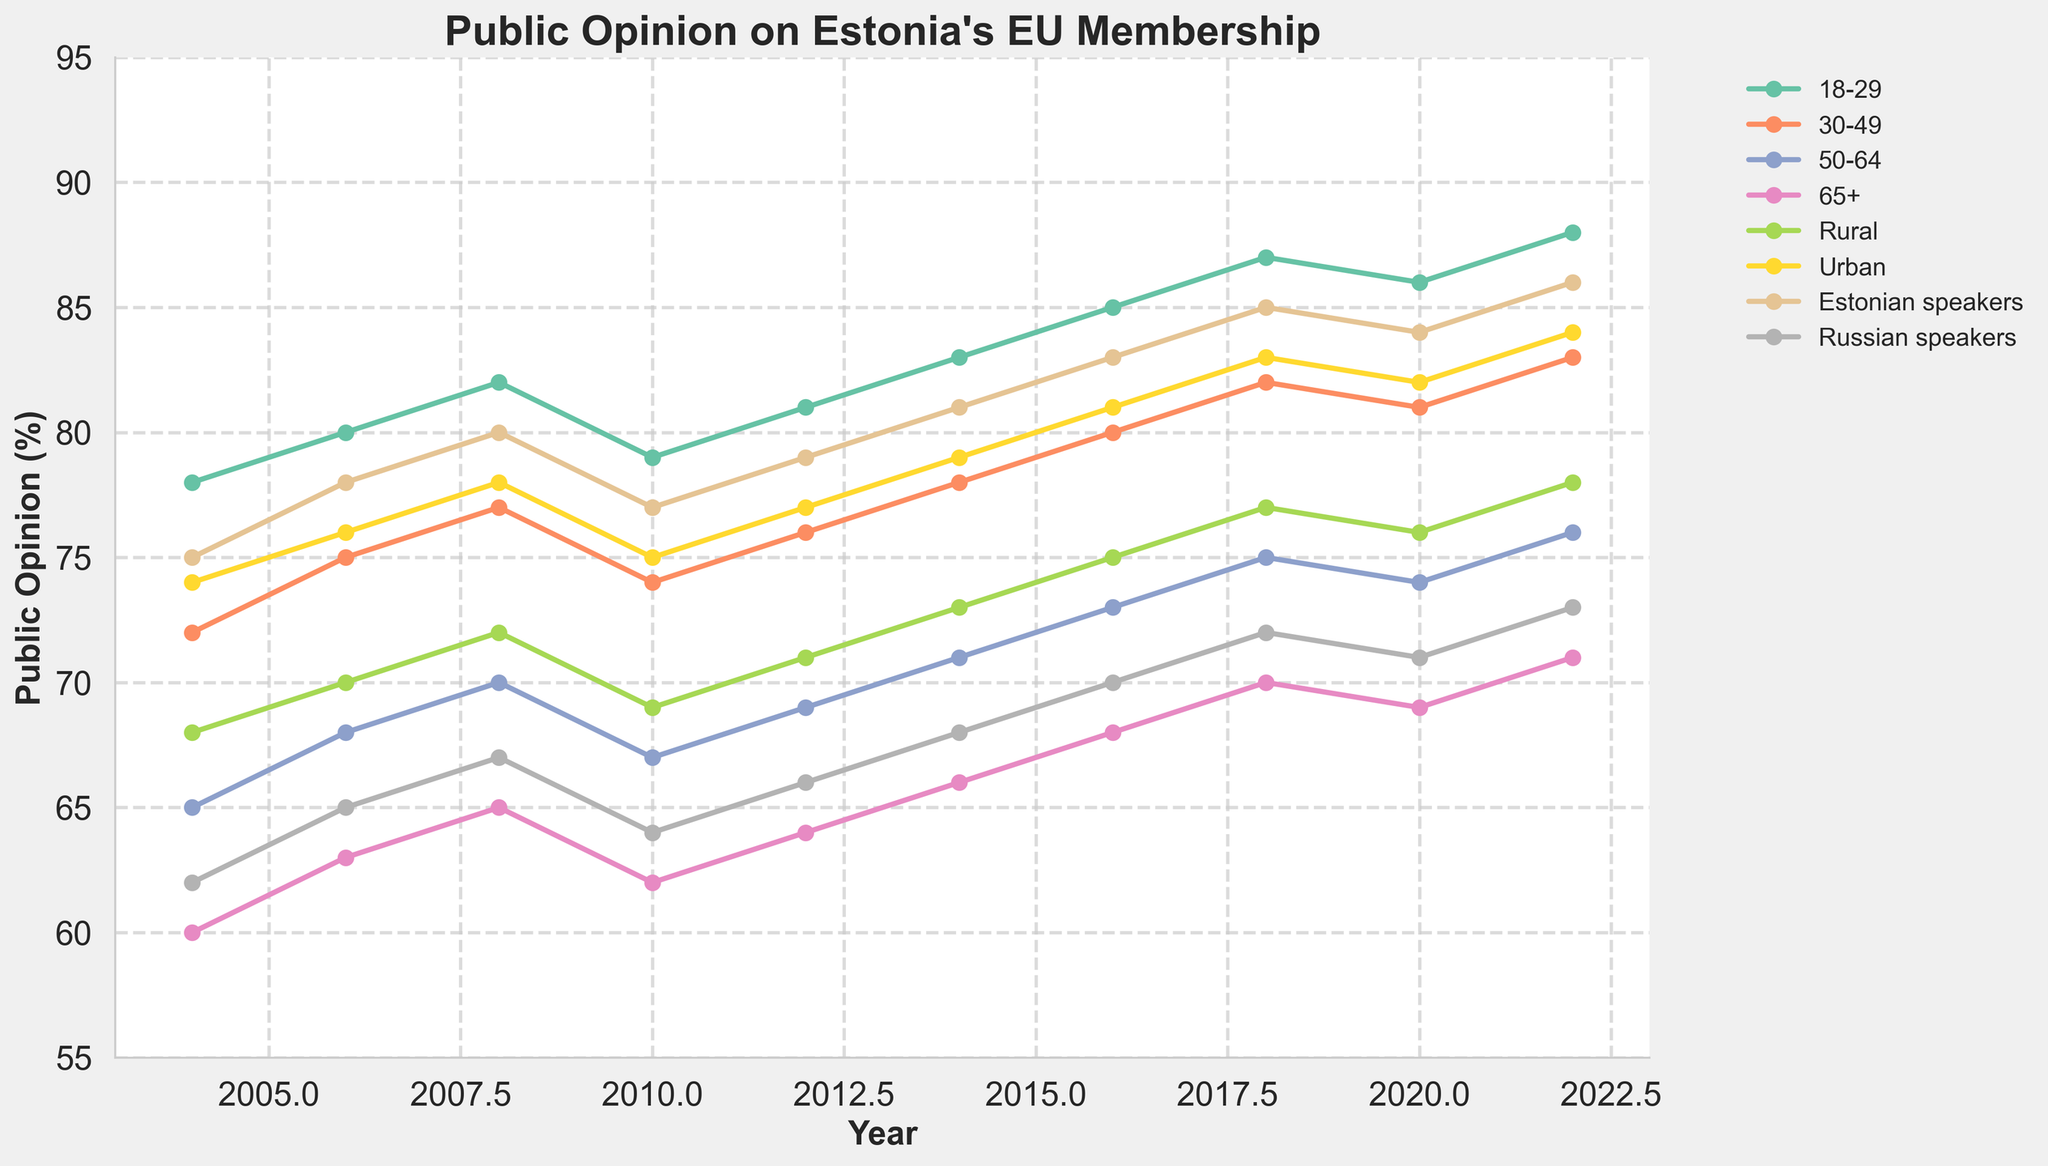What's the public opinion percentage difference between the 18-29 and 65+ age groups in 2022? To find the difference, subtract the public opinion percentage of the 65+ group from that of the 18-29 group for the year 2022. In 2022, the 18-29 age group is at 88%, and the 65+ age group is at 71%. So, the difference is 88% - 71% = 17%.
Answer: 17% Which demographic group's support for EU membership has shown the greatest increase from 2004 to 2022? Compare the differences in values from 2004 to 2022 for each demographic group. The group with the highest difference shows the greatest increase. For the 18-29 group, it's 88% - 78% = 10%. For the 30-49 group, it's 83% - 72% = 11%. For the 50-64 group, it's 76% - 65% = 11%. For the 65+ group, it's 71% - 60% = 11%. For the Rural group, it's 78% - 68% = 10%. For the Urban group, it's 84% - 74% = 10%. For Estonian speakers, it's 86% - 75% = 11%. For Russian speakers, it's 73% - 62% = 11%. Several groups (30-49, 50-64, 65+, and Estonian speakers) share an equal greatest increase of 11%.
Answer: 30-49, 50-64, 65+, Estonian speakers, Russian speakers In which year did the 30-49 age group show the same level of support as the Urban demographic in 2020? First, find the Urban group’s support in 2020, which is 82%. Next, look for the year in the 30-49 age group that had the same value. In 2020, the 30-49 age group also had 82%.
Answer: 2020 What is the average public opinion percentage across all demographic groups in 2022? To find the average, sum the values for all groups in the year 2022 and then divide by the number of groups. The sum for 2022 is 88% + 83% + 76% + 71% + 78% + 84% + 86% + 73% = 639%. There are 8 demographic groups, so the average is 639% / 8 ≈ 79.88%.
Answer: 79.88% Which group had the same or higher support than the Rural group in 2008 and by how much? First, identify the support level for the Rural group in 2008, which is 72%. Now compare it with other groups: 18-29 (82%), 30-49 (77%), 50-64 (70%), 65+ (65%), Urban (78%), Estonian speakers (80%), Russian speakers (67%). The groups with the same or higher support are: 18-29 (82% - 72% = 10%), 30-49 (77% - 72% = 5%), Urban (78% - 72% = 6%), Estonian speakers (80% - 72% = 8%).
Answer: 18-29 (10%), 30-49 (5%), Urban (6%), Estonian speakers (8%) How did the opinion of the Russian speakers on Estonia's EU membership change from 2004 to 2012? Subtract the Russian speakers' support in 2004 from their support in 2012. In 2004, it's 62%, and in 2012, it's 66%. So the change is 66% - 62% = 4%.
Answer: 4% What visual trend can be observed about urban support for EU membership over time? The trend line for the Urban demographic consistently shows an upward trajectory from 2004 to 2022, indicating increase in support for EU membership over time.
Answer: Increasing trend Which age group has the most stable level of support for EU membership from 2004 to 2022? To determine stability, observe which age group has the least fluctuation in percentages across years. The 18-29 group's support ranges from 78% to 88%, the 30-49 group from 72% to 83%, the 50-64 group from 65% to 76%, and the 65+ group from 60% to 71%. The 18-29 group has comparatively less fluctuation.
Answer: 18-29 In which demographic does the support for EU membership in 2016 surpass the 2020 Rural support level? First, identify the Rural group's support in 2020, which is 76%. Then, check the values for all groups in 2016. 18-29 had 85%, 30-49 had 80%, 50-64 had 73%, 65+ had 68%, Urban had 81%, Estonian speakers had 83%, and Russian speakers had 70%. The groups surpassing 76% are 18-29 (85%), 30-49 (80%), and Urban (81%).
Answer: 18-29, 30-49, Urban 